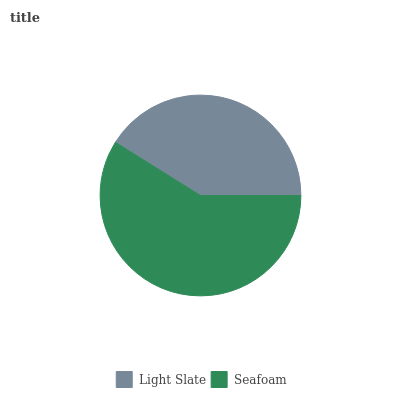Is Light Slate the minimum?
Answer yes or no. Yes. Is Seafoam the maximum?
Answer yes or no. Yes. Is Seafoam the minimum?
Answer yes or no. No. Is Seafoam greater than Light Slate?
Answer yes or no. Yes. Is Light Slate less than Seafoam?
Answer yes or no. Yes. Is Light Slate greater than Seafoam?
Answer yes or no. No. Is Seafoam less than Light Slate?
Answer yes or no. No. Is Seafoam the high median?
Answer yes or no. Yes. Is Light Slate the low median?
Answer yes or no. Yes. Is Light Slate the high median?
Answer yes or no. No. Is Seafoam the low median?
Answer yes or no. No. 